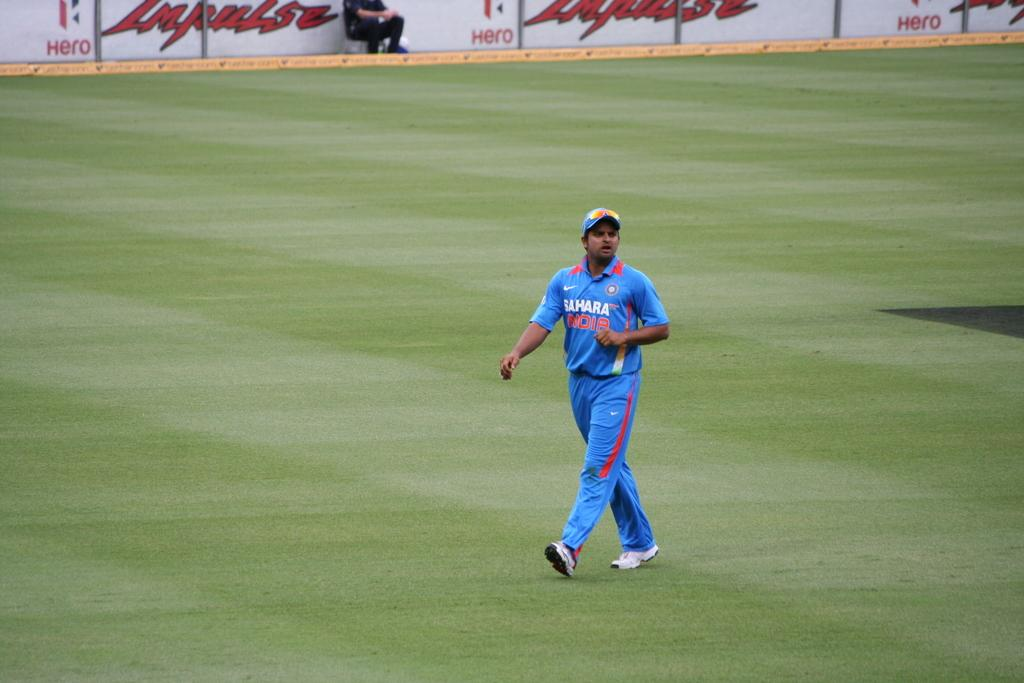<image>
Write a terse but informative summary of the picture. A man's uniform shirt is sponsored by Nike and says Sahara across the top. 